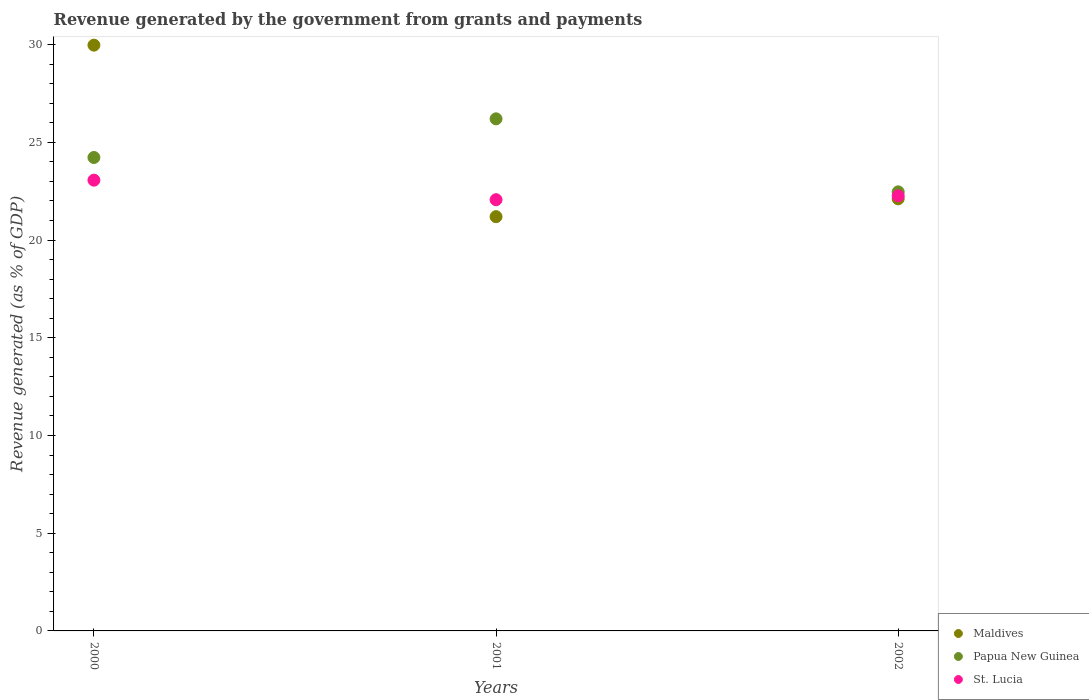How many different coloured dotlines are there?
Ensure brevity in your answer.  3. Is the number of dotlines equal to the number of legend labels?
Your answer should be compact. Yes. What is the revenue generated by the government in Maldives in 2002?
Give a very brief answer. 22.11. Across all years, what is the maximum revenue generated by the government in Maldives?
Provide a succinct answer. 29.97. Across all years, what is the minimum revenue generated by the government in Maldives?
Provide a succinct answer. 21.2. What is the total revenue generated by the government in St. Lucia in the graph?
Offer a very short reply. 67.4. What is the difference between the revenue generated by the government in Papua New Guinea in 2000 and that in 2002?
Your answer should be compact. 1.76. What is the difference between the revenue generated by the government in St. Lucia in 2002 and the revenue generated by the government in Maldives in 2000?
Keep it short and to the point. -7.71. What is the average revenue generated by the government in St. Lucia per year?
Offer a terse response. 22.47. In the year 2001, what is the difference between the revenue generated by the government in Maldives and revenue generated by the government in Papua New Guinea?
Provide a succinct answer. -5.01. In how many years, is the revenue generated by the government in Papua New Guinea greater than 13 %?
Ensure brevity in your answer.  3. What is the ratio of the revenue generated by the government in Papua New Guinea in 2001 to that in 2002?
Keep it short and to the point. 1.17. What is the difference between the highest and the second highest revenue generated by the government in St. Lucia?
Offer a terse response. 0.8. What is the difference between the highest and the lowest revenue generated by the government in St. Lucia?
Ensure brevity in your answer.  1. Is the sum of the revenue generated by the government in Maldives in 2000 and 2001 greater than the maximum revenue generated by the government in Papua New Guinea across all years?
Your answer should be very brief. Yes. Does the revenue generated by the government in Maldives monotonically increase over the years?
Your answer should be very brief. No. Is the revenue generated by the government in Maldives strictly greater than the revenue generated by the government in St. Lucia over the years?
Provide a succinct answer. No. Is the revenue generated by the government in St. Lucia strictly less than the revenue generated by the government in Maldives over the years?
Offer a very short reply. No. How many dotlines are there?
Make the answer very short. 3. Are the values on the major ticks of Y-axis written in scientific E-notation?
Your response must be concise. No. Does the graph contain any zero values?
Offer a very short reply. No. How many legend labels are there?
Provide a succinct answer. 3. What is the title of the graph?
Offer a terse response. Revenue generated by the government from grants and payments. What is the label or title of the Y-axis?
Your answer should be compact. Revenue generated (as % of GDP). What is the Revenue generated (as % of GDP) in Maldives in 2000?
Keep it short and to the point. 29.97. What is the Revenue generated (as % of GDP) of Papua New Guinea in 2000?
Your response must be concise. 24.23. What is the Revenue generated (as % of GDP) of St. Lucia in 2000?
Your answer should be very brief. 23.06. What is the Revenue generated (as % of GDP) of Maldives in 2001?
Provide a short and direct response. 21.2. What is the Revenue generated (as % of GDP) in Papua New Guinea in 2001?
Ensure brevity in your answer.  26.2. What is the Revenue generated (as % of GDP) in St. Lucia in 2001?
Ensure brevity in your answer.  22.07. What is the Revenue generated (as % of GDP) of Maldives in 2002?
Your answer should be compact. 22.11. What is the Revenue generated (as % of GDP) of Papua New Guinea in 2002?
Offer a very short reply. 22.47. What is the Revenue generated (as % of GDP) in St. Lucia in 2002?
Ensure brevity in your answer.  22.27. Across all years, what is the maximum Revenue generated (as % of GDP) of Maldives?
Give a very brief answer. 29.97. Across all years, what is the maximum Revenue generated (as % of GDP) of Papua New Guinea?
Make the answer very short. 26.2. Across all years, what is the maximum Revenue generated (as % of GDP) of St. Lucia?
Provide a succinct answer. 23.06. Across all years, what is the minimum Revenue generated (as % of GDP) of Maldives?
Your answer should be very brief. 21.2. Across all years, what is the minimum Revenue generated (as % of GDP) in Papua New Guinea?
Give a very brief answer. 22.47. Across all years, what is the minimum Revenue generated (as % of GDP) of St. Lucia?
Make the answer very short. 22.07. What is the total Revenue generated (as % of GDP) of Maldives in the graph?
Keep it short and to the point. 73.28. What is the total Revenue generated (as % of GDP) in Papua New Guinea in the graph?
Ensure brevity in your answer.  72.9. What is the total Revenue generated (as % of GDP) of St. Lucia in the graph?
Give a very brief answer. 67.4. What is the difference between the Revenue generated (as % of GDP) of Maldives in 2000 and that in 2001?
Your answer should be very brief. 8.78. What is the difference between the Revenue generated (as % of GDP) of Papua New Guinea in 2000 and that in 2001?
Give a very brief answer. -1.98. What is the difference between the Revenue generated (as % of GDP) in St. Lucia in 2000 and that in 2001?
Ensure brevity in your answer.  1. What is the difference between the Revenue generated (as % of GDP) of Maldives in 2000 and that in 2002?
Your answer should be compact. 7.86. What is the difference between the Revenue generated (as % of GDP) in Papua New Guinea in 2000 and that in 2002?
Offer a terse response. 1.76. What is the difference between the Revenue generated (as % of GDP) in St. Lucia in 2000 and that in 2002?
Keep it short and to the point. 0.8. What is the difference between the Revenue generated (as % of GDP) of Maldives in 2001 and that in 2002?
Offer a terse response. -0.91. What is the difference between the Revenue generated (as % of GDP) of Papua New Guinea in 2001 and that in 2002?
Provide a succinct answer. 3.74. What is the difference between the Revenue generated (as % of GDP) in St. Lucia in 2001 and that in 2002?
Keep it short and to the point. -0.2. What is the difference between the Revenue generated (as % of GDP) in Maldives in 2000 and the Revenue generated (as % of GDP) in Papua New Guinea in 2001?
Keep it short and to the point. 3.77. What is the difference between the Revenue generated (as % of GDP) in Maldives in 2000 and the Revenue generated (as % of GDP) in St. Lucia in 2001?
Your answer should be compact. 7.91. What is the difference between the Revenue generated (as % of GDP) in Papua New Guinea in 2000 and the Revenue generated (as % of GDP) in St. Lucia in 2001?
Provide a succinct answer. 2.16. What is the difference between the Revenue generated (as % of GDP) of Maldives in 2000 and the Revenue generated (as % of GDP) of Papua New Guinea in 2002?
Make the answer very short. 7.51. What is the difference between the Revenue generated (as % of GDP) in Maldives in 2000 and the Revenue generated (as % of GDP) in St. Lucia in 2002?
Your answer should be compact. 7.71. What is the difference between the Revenue generated (as % of GDP) in Papua New Guinea in 2000 and the Revenue generated (as % of GDP) in St. Lucia in 2002?
Provide a succinct answer. 1.96. What is the difference between the Revenue generated (as % of GDP) in Maldives in 2001 and the Revenue generated (as % of GDP) in Papua New Guinea in 2002?
Provide a short and direct response. -1.27. What is the difference between the Revenue generated (as % of GDP) in Maldives in 2001 and the Revenue generated (as % of GDP) in St. Lucia in 2002?
Keep it short and to the point. -1.07. What is the difference between the Revenue generated (as % of GDP) in Papua New Guinea in 2001 and the Revenue generated (as % of GDP) in St. Lucia in 2002?
Provide a short and direct response. 3.94. What is the average Revenue generated (as % of GDP) of Maldives per year?
Provide a short and direct response. 24.43. What is the average Revenue generated (as % of GDP) of Papua New Guinea per year?
Provide a succinct answer. 24.3. What is the average Revenue generated (as % of GDP) in St. Lucia per year?
Your answer should be very brief. 22.47. In the year 2000, what is the difference between the Revenue generated (as % of GDP) in Maldives and Revenue generated (as % of GDP) in Papua New Guinea?
Your answer should be compact. 5.75. In the year 2000, what is the difference between the Revenue generated (as % of GDP) of Maldives and Revenue generated (as % of GDP) of St. Lucia?
Offer a very short reply. 6.91. In the year 2000, what is the difference between the Revenue generated (as % of GDP) of Papua New Guinea and Revenue generated (as % of GDP) of St. Lucia?
Ensure brevity in your answer.  1.16. In the year 2001, what is the difference between the Revenue generated (as % of GDP) in Maldives and Revenue generated (as % of GDP) in Papua New Guinea?
Your answer should be compact. -5.01. In the year 2001, what is the difference between the Revenue generated (as % of GDP) of Maldives and Revenue generated (as % of GDP) of St. Lucia?
Your answer should be compact. -0.87. In the year 2001, what is the difference between the Revenue generated (as % of GDP) in Papua New Guinea and Revenue generated (as % of GDP) in St. Lucia?
Your answer should be compact. 4.14. In the year 2002, what is the difference between the Revenue generated (as % of GDP) in Maldives and Revenue generated (as % of GDP) in Papua New Guinea?
Offer a terse response. -0.36. In the year 2002, what is the difference between the Revenue generated (as % of GDP) in Maldives and Revenue generated (as % of GDP) in St. Lucia?
Your answer should be very brief. -0.15. In the year 2002, what is the difference between the Revenue generated (as % of GDP) of Papua New Guinea and Revenue generated (as % of GDP) of St. Lucia?
Offer a terse response. 0.2. What is the ratio of the Revenue generated (as % of GDP) in Maldives in 2000 to that in 2001?
Give a very brief answer. 1.41. What is the ratio of the Revenue generated (as % of GDP) of Papua New Guinea in 2000 to that in 2001?
Offer a terse response. 0.92. What is the ratio of the Revenue generated (as % of GDP) of St. Lucia in 2000 to that in 2001?
Make the answer very short. 1.05. What is the ratio of the Revenue generated (as % of GDP) in Maldives in 2000 to that in 2002?
Your response must be concise. 1.36. What is the ratio of the Revenue generated (as % of GDP) of Papua New Guinea in 2000 to that in 2002?
Ensure brevity in your answer.  1.08. What is the ratio of the Revenue generated (as % of GDP) in St. Lucia in 2000 to that in 2002?
Offer a terse response. 1.04. What is the ratio of the Revenue generated (as % of GDP) in Maldives in 2001 to that in 2002?
Offer a terse response. 0.96. What is the ratio of the Revenue generated (as % of GDP) in Papua New Guinea in 2001 to that in 2002?
Your response must be concise. 1.17. What is the difference between the highest and the second highest Revenue generated (as % of GDP) of Maldives?
Your answer should be compact. 7.86. What is the difference between the highest and the second highest Revenue generated (as % of GDP) in Papua New Guinea?
Ensure brevity in your answer.  1.98. What is the difference between the highest and the second highest Revenue generated (as % of GDP) in St. Lucia?
Offer a very short reply. 0.8. What is the difference between the highest and the lowest Revenue generated (as % of GDP) of Maldives?
Provide a succinct answer. 8.78. What is the difference between the highest and the lowest Revenue generated (as % of GDP) in Papua New Guinea?
Keep it short and to the point. 3.74. What is the difference between the highest and the lowest Revenue generated (as % of GDP) of St. Lucia?
Your answer should be very brief. 1. 